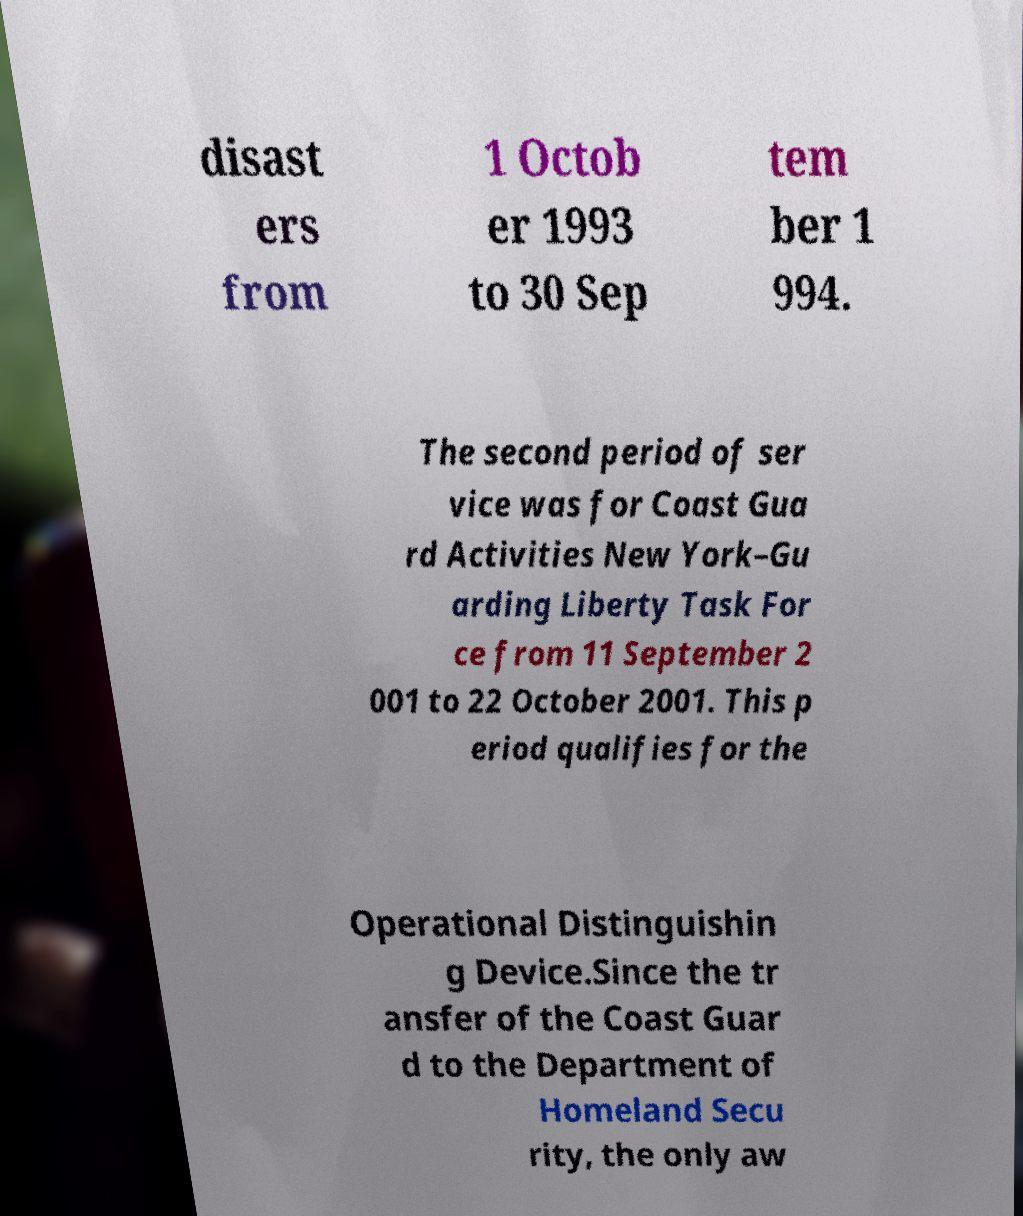Can you accurately transcribe the text from the provided image for me? disast ers from 1 Octob er 1993 to 30 Sep tem ber 1 994. The second period of ser vice was for Coast Gua rd Activities New York–Gu arding Liberty Task For ce from 11 September 2 001 to 22 October 2001. This p eriod qualifies for the Operational Distinguishin g Device.Since the tr ansfer of the Coast Guar d to the Department of Homeland Secu rity, the only aw 